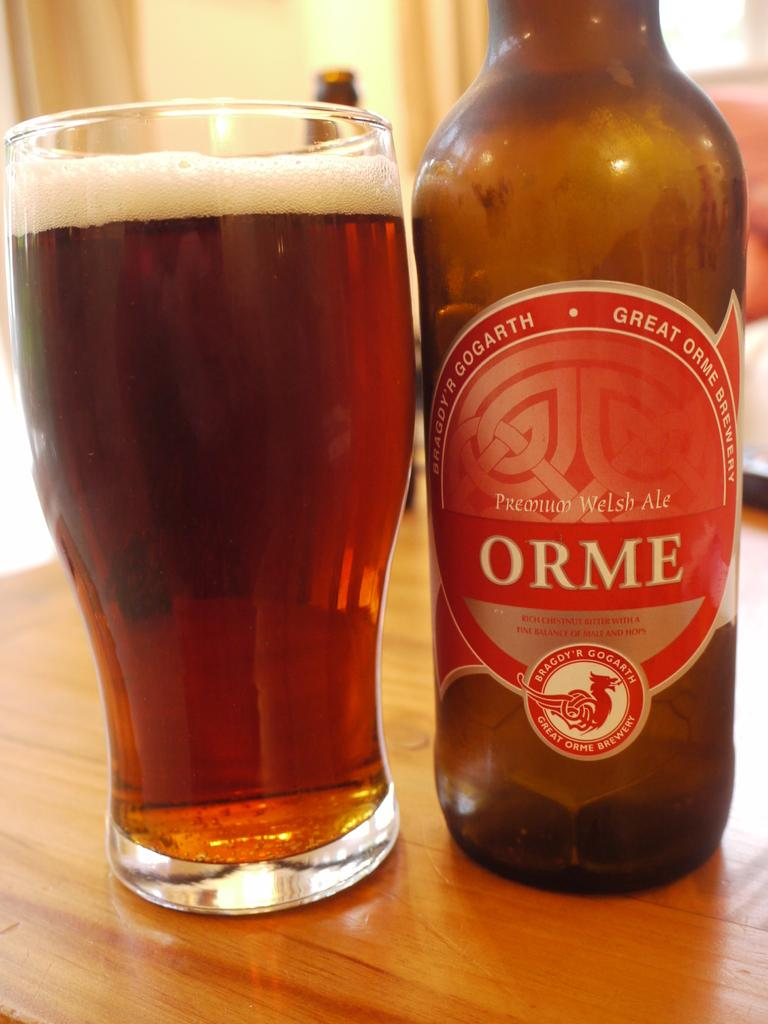Provide a one-sentence caption for the provided image. A bottle and glass of ORME beer sits on a table. 